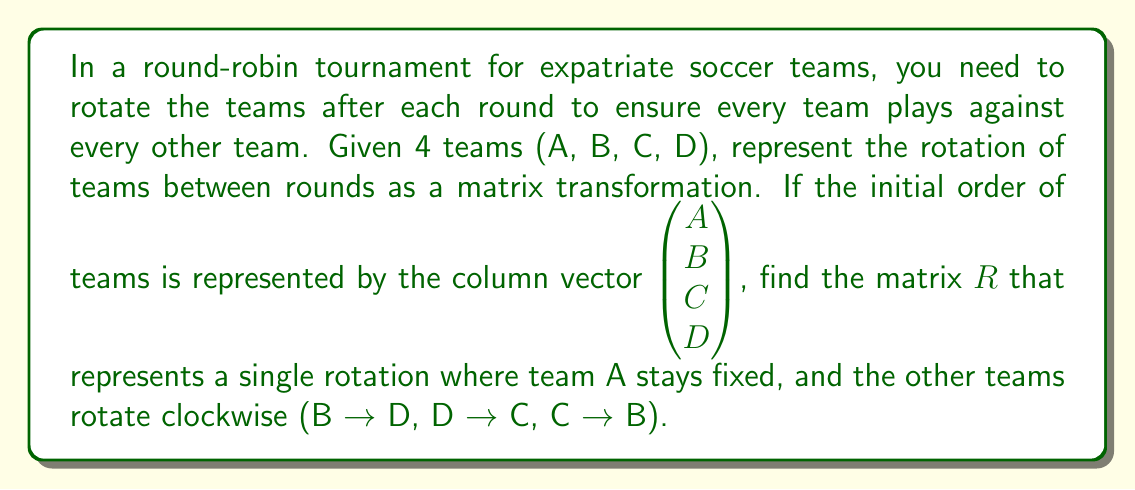Can you solve this math problem? To solve this problem, we need to follow these steps:

1) First, let's understand what the rotation does:
   - A stays in place
   - B moves to D's position
   - C moves to B's position
   - D moves to C's position

2) We can represent this transformation as a matrix equation:

   $$R \begin{pmatrix} A \\ B \\ C \\ D \end{pmatrix} = \begin{pmatrix} A \\ D \\ B \\ C \end{pmatrix}$$

3) Now, let's consider what each row of the matrix $R$ should do:
   - The first row should keep A in place: $(1, 0, 0, 0)$
   - The second row should move D to B's place: $(0, 0, 0, 1)$
   - The third row should move B to C's place: $(0, 1, 0, 0)$
   - The fourth row should move C to D's place: $(0, 0, 1, 0)$

4) Combining these rows, we get the rotation matrix $R$:

   $$R = \begin{pmatrix} 
   1 & 0 & 0 & 0 \\
   0 & 0 & 0 & 1 \\
   0 & 1 & 0 & 0 \\
   0 & 0 & 1 & 0
   \end{pmatrix}$$

5) We can verify this matrix works by multiplying it with the initial vector:

   $$\begin{pmatrix} 
   1 & 0 & 0 & 0 \\
   0 & 0 & 0 & 1 \\
   0 & 1 & 0 & 0 \\
   0 & 0 & 1 & 0
   \end{pmatrix}
   \begin{pmatrix} A \\ B \\ C \\ D \end{pmatrix}
   = \begin{pmatrix} A \\ D \\ B \\ C \end{pmatrix}$$

This confirms that our matrix $R$ correctly represents the desired rotation.
Answer: The matrix representation $R$ for the team rotation is:

$$R = \begin{pmatrix} 
1 & 0 & 0 & 0 \\
0 & 0 & 0 & 1 \\
0 & 1 & 0 & 0 \\
0 & 0 & 1 & 0
\end{pmatrix}$$ 